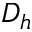<formula> <loc_0><loc_0><loc_500><loc_500>D _ { h }</formula> 